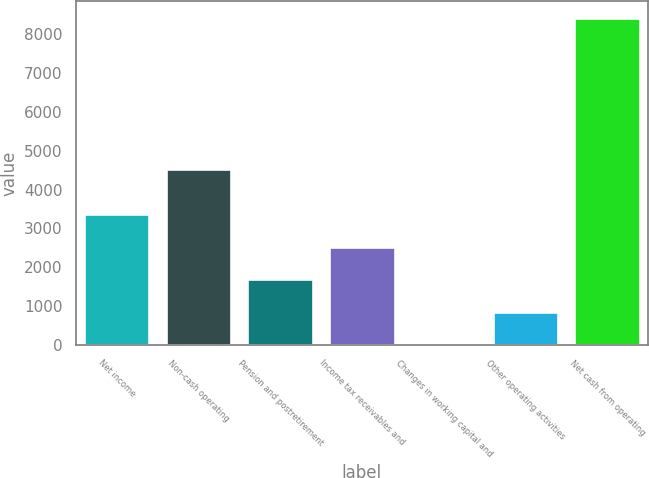<chart> <loc_0><loc_0><loc_500><loc_500><bar_chart><fcel>Net income<fcel>Non-cash operating<fcel>Pension and postretirement<fcel>Income tax receivables and<fcel>Changes in working capital and<fcel>Other operating activities<fcel>Net cash from operating<nl><fcel>3374<fcel>4539<fcel>1690<fcel>2532<fcel>6<fcel>848<fcel>8426<nl></chart> 